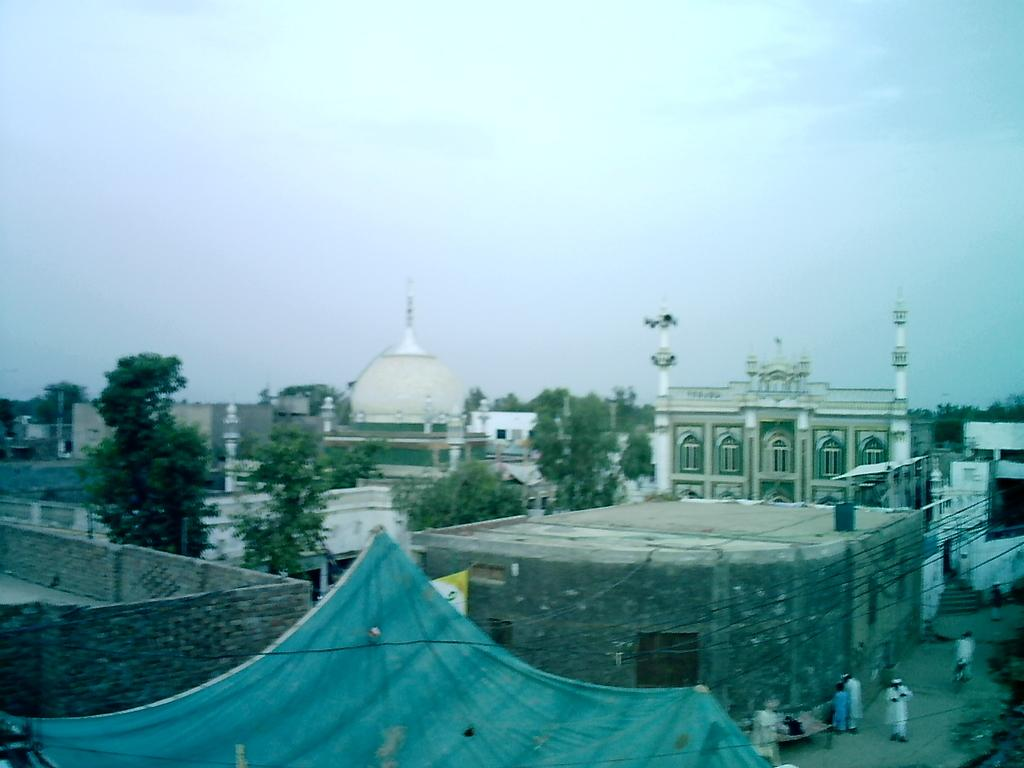What type of structures can be seen in the image? There are buildings in the image. What else is present in the image besides buildings? There are cables, people, trees, and clouds visible in the image. Can you describe the people in the image? The image shows people, but their specific actions or characteristics are not mentioned in the provided facts. What is visible in the background of the image? There are trees and clouds in the background of the image. What type of appliance is being used by the frog in the image? There is no frog present in the image, and therefore no appliance can be associated with it. 